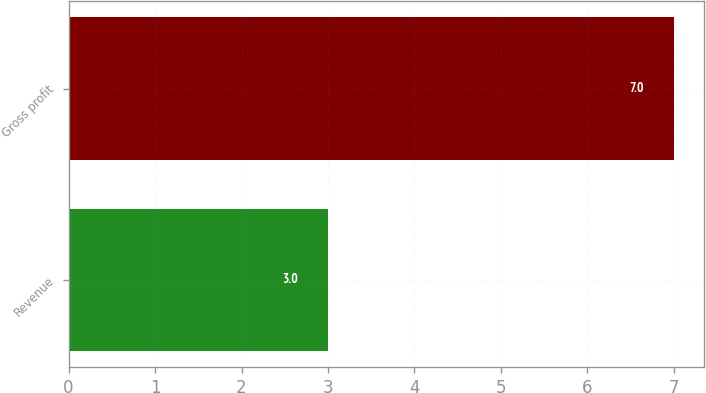Convert chart. <chart><loc_0><loc_0><loc_500><loc_500><bar_chart><fcel>Revenue<fcel>Gross profit<nl><fcel>3<fcel>7<nl></chart> 